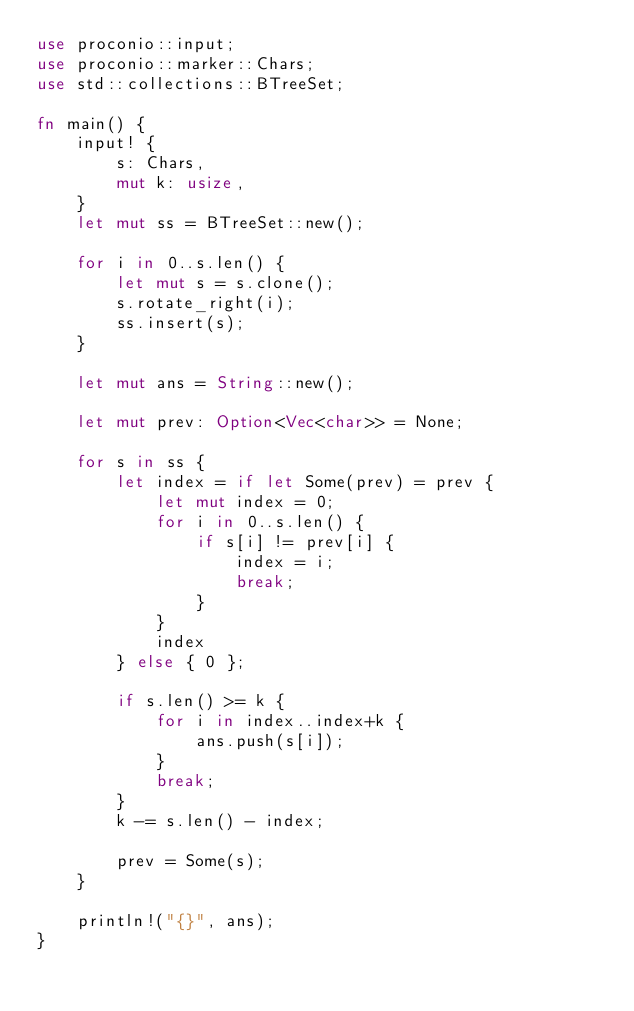<code> <loc_0><loc_0><loc_500><loc_500><_Rust_>use proconio::input;
use proconio::marker::Chars;
use std::collections::BTreeSet;

fn main() {
    input! {
        s: Chars,
        mut k: usize,
    }
    let mut ss = BTreeSet::new();

    for i in 0..s.len() {
        let mut s = s.clone();
        s.rotate_right(i);
        ss.insert(s);
    }

    let mut ans = String::new();

    let mut prev: Option<Vec<char>> = None;

    for s in ss {
        let index = if let Some(prev) = prev {
            let mut index = 0;
            for i in 0..s.len() {
                if s[i] != prev[i] {
                    index = i;
                    break;
                }
            }
            index
        } else { 0 };

        if s.len() >= k {
            for i in index..index+k {
                ans.push(s[i]);
            }
            break;
        }
        k -= s.len() - index;

        prev = Some(s);
    }

    println!("{}", ans);
}

</code> 